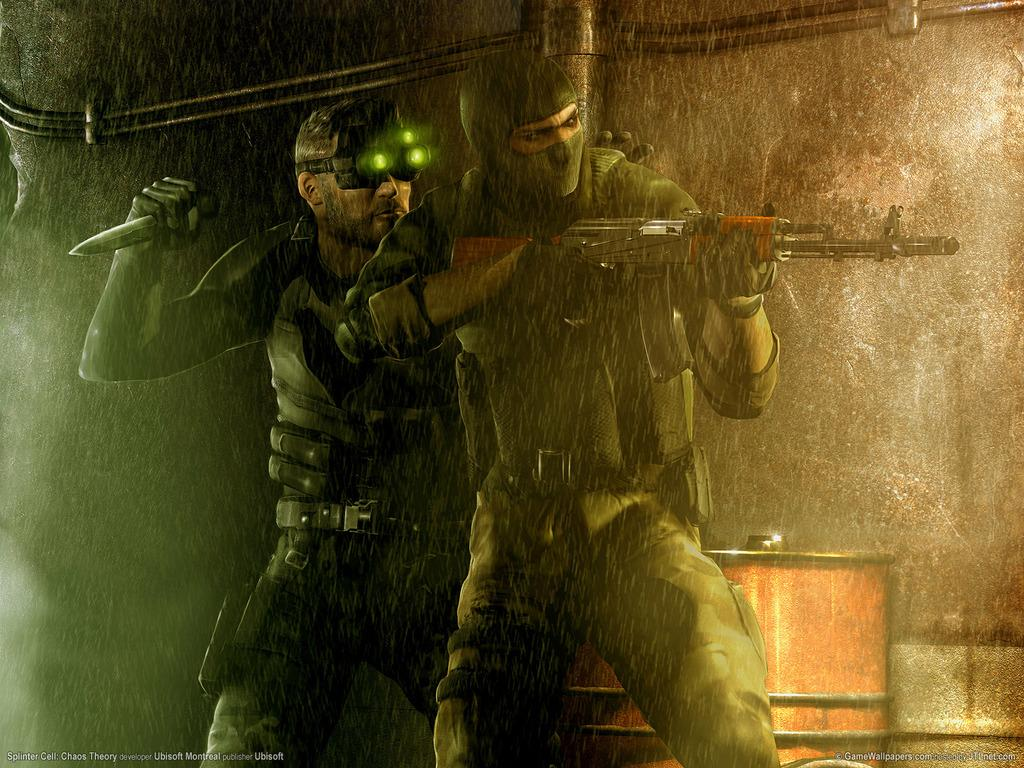How many people are in the image? There are two persons in the image. What are the persons holding in the image? The persons are holding weapons. What is the color of the background in the image? The background of the image is dark. What can be seen in the background of the image? There are objects visible in the background. What type of cactus can be seen growing in the image? There is no cactus present in the image. What kind of structure is visible in the background of the image? The provided facts do not mention any specific structures in the background, so we cannot determine the type of structure. 